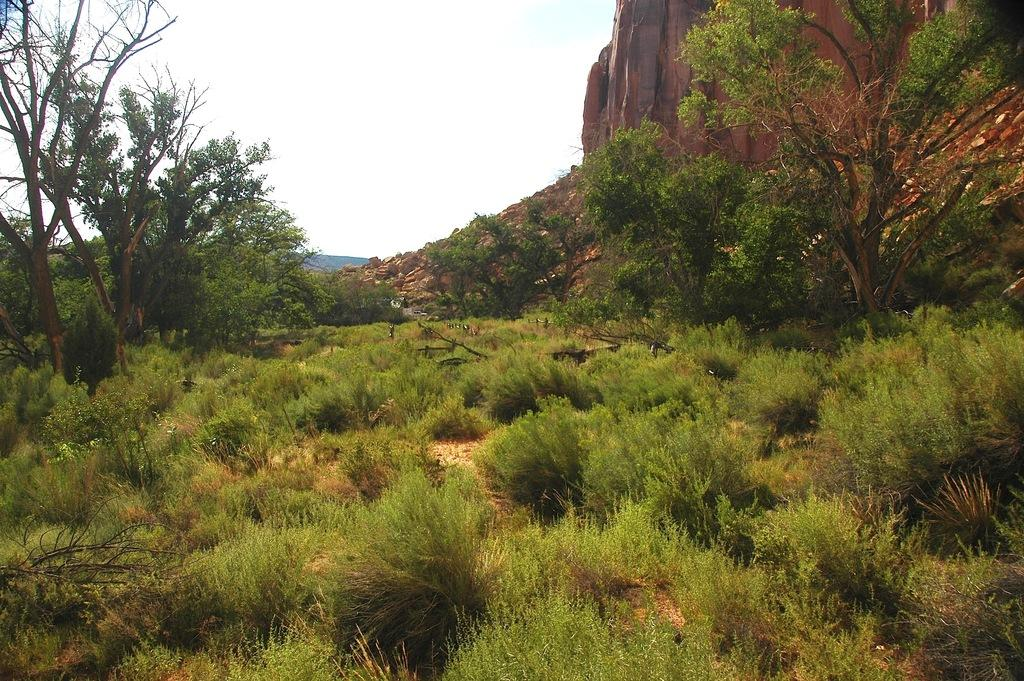What type of vegetation is in the front of the image? There are plants in the front of the image. What can be seen in the background of the image? There are trees, rocks, mountains, and the sky visible in the background of the image. What type of sock is hanging from the tree in the image? There is no sock present in the image; it features plants, trees, rocks, mountains, and the sky. What attraction can be seen in the image? The image does not depict any specific attraction; it shows a natural landscape with plants, trees, rocks, mountains, and the sky. 